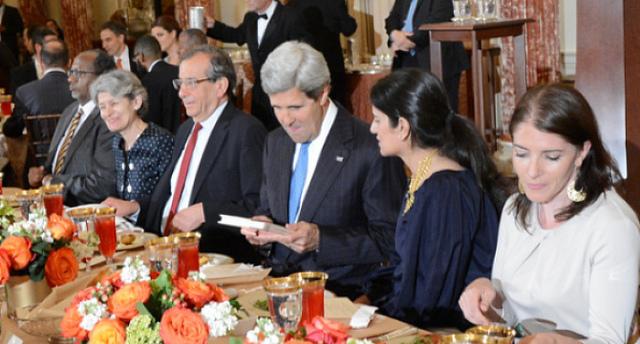Is there a blue tie?
Concise answer only. Yes. Are the second and third person from the front engaged in a conversation?
Write a very short answer. Yes. What type of dining function is this?
Answer briefly. Political. 